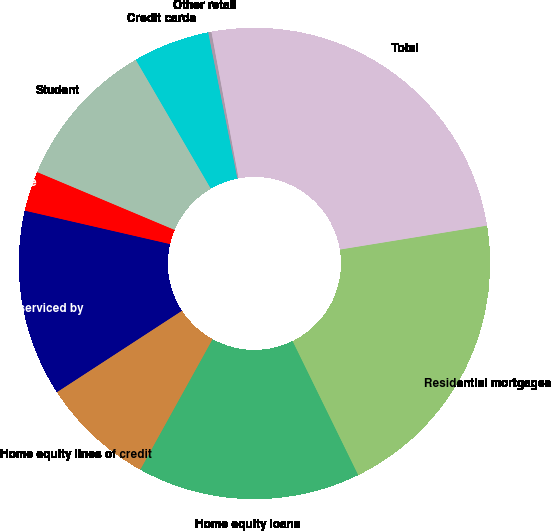Convert chart. <chart><loc_0><loc_0><loc_500><loc_500><pie_chart><fcel>Residential mortgages<fcel>Home equity loans<fcel>Home equity lines of credit<fcel>Home equity loans serviced by<fcel>Automobile<fcel>Student<fcel>Credit cards<fcel>Other retail<fcel>Total<nl><fcel>20.32%<fcel>15.3%<fcel>7.76%<fcel>12.79%<fcel>2.74%<fcel>10.27%<fcel>5.25%<fcel>0.22%<fcel>25.35%<nl></chart> 